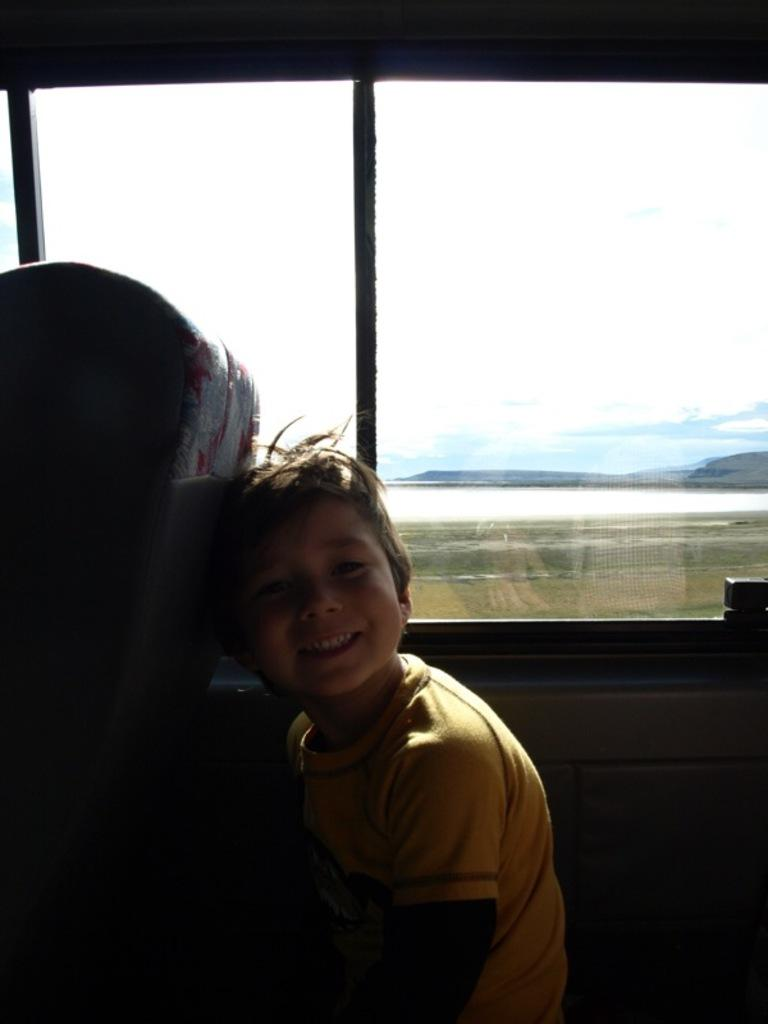What is the boy doing in the image? The boy is riding in a vehicle in the image. What type of landscape can be seen in the background? There are mountains and a river in the image, along with grass visible on the surface. What is visible at the top of the image? The sky is visible at the top of the image. What decision is the boy making while riding in the vehicle? There is no indication in the image of the boy making any decisions while riding in the vehicle. What type of oven can be seen in the image? There is no oven present in the image. 